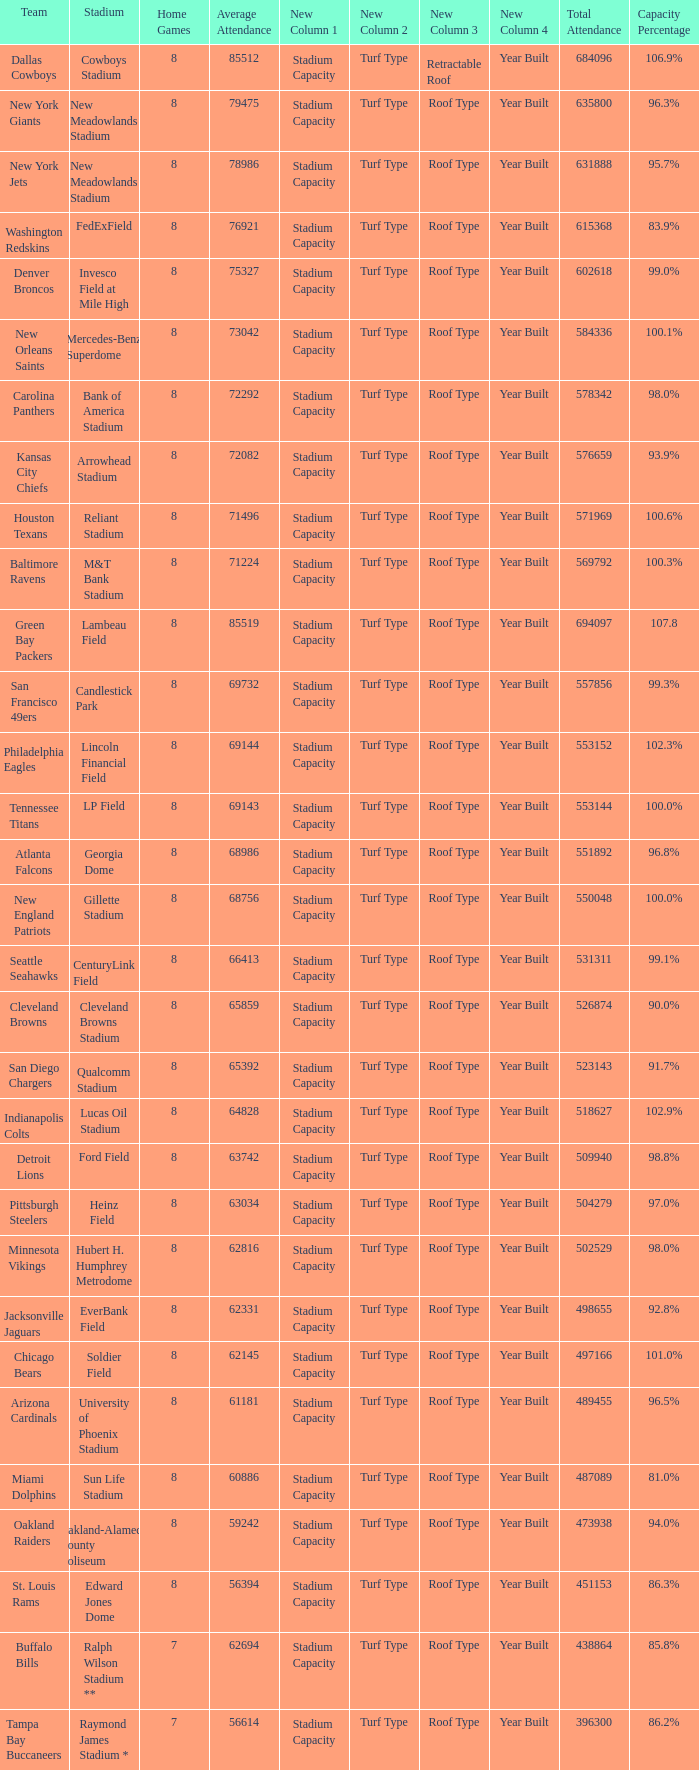Would you be able to parse every entry in this table? {'header': ['Team', 'Stadium', 'Home Games', 'Average Attendance', 'New Column 1', 'New Column 2', 'New Column 3', 'New Column 4', 'Total Attendance', 'Capacity Percentage'], 'rows': [['Dallas Cowboys', 'Cowboys Stadium', '8', '85512', 'Stadium Capacity', 'Turf Type', 'Retractable Roof', 'Year Built', '684096', '106.9%'], ['New York Giants', 'New Meadowlands Stadium', '8', '79475', 'Stadium Capacity', 'Turf Type', 'Roof Type', 'Year Built', '635800', '96.3%'], ['New York Jets', 'New Meadowlands Stadium', '8', '78986', 'Stadium Capacity', 'Turf Type', 'Roof Type', 'Year Built', '631888', '95.7%'], ['Washington Redskins', 'FedExField', '8', '76921', 'Stadium Capacity', 'Turf Type', 'Roof Type', 'Year Built', '615368', '83.9%'], ['Denver Broncos', 'Invesco Field at Mile High', '8', '75327', 'Stadium Capacity', 'Turf Type', 'Roof Type', 'Year Built', '602618', '99.0%'], ['New Orleans Saints', 'Mercedes-Benz Superdome', '8', '73042', 'Stadium Capacity', 'Turf Type', 'Roof Type', 'Year Built', '584336', '100.1%'], ['Carolina Panthers', 'Bank of America Stadium', '8', '72292', 'Stadium Capacity', 'Turf Type', 'Roof Type', 'Year Built', '578342', '98.0%'], ['Kansas City Chiefs', 'Arrowhead Stadium', '8', '72082', 'Stadium Capacity', 'Turf Type', 'Roof Type', 'Year Built', '576659', '93.9%'], ['Houston Texans', 'Reliant Stadium', '8', '71496', 'Stadium Capacity', 'Turf Type', 'Roof Type', 'Year Built', '571969', '100.6%'], ['Baltimore Ravens', 'M&T Bank Stadium', '8', '71224', 'Stadium Capacity', 'Turf Type', 'Roof Type', 'Year Built', '569792', '100.3%'], ['Green Bay Packers', 'Lambeau Field', '8', '85519', 'Stadium Capacity', 'Turf Type', 'Roof Type', 'Year Built', '694097', '107.8'], ['San Francisco 49ers', 'Candlestick Park', '8', '69732', 'Stadium Capacity', 'Turf Type', 'Roof Type', 'Year Built', '557856', '99.3%'], ['Philadelphia Eagles', 'Lincoln Financial Field', '8', '69144', 'Stadium Capacity', 'Turf Type', 'Roof Type', 'Year Built', '553152', '102.3%'], ['Tennessee Titans', 'LP Field', '8', '69143', 'Stadium Capacity', 'Turf Type', 'Roof Type', 'Year Built', '553144', '100.0%'], ['Atlanta Falcons', 'Georgia Dome', '8', '68986', 'Stadium Capacity', 'Turf Type', 'Roof Type', 'Year Built', '551892', '96.8%'], ['New England Patriots', 'Gillette Stadium', '8', '68756', 'Stadium Capacity', 'Turf Type', 'Roof Type', 'Year Built', '550048', '100.0%'], ['Seattle Seahawks', 'CenturyLink Field', '8', '66413', 'Stadium Capacity', 'Turf Type', 'Roof Type', 'Year Built', '531311', '99.1%'], ['Cleveland Browns', 'Cleveland Browns Stadium', '8', '65859', 'Stadium Capacity', 'Turf Type', 'Roof Type', 'Year Built', '526874', '90.0%'], ['San Diego Chargers', 'Qualcomm Stadium', '8', '65392', 'Stadium Capacity', 'Turf Type', 'Roof Type', 'Year Built', '523143', '91.7%'], ['Indianapolis Colts', 'Lucas Oil Stadium', '8', '64828', 'Stadium Capacity', 'Turf Type', 'Roof Type', 'Year Built', '518627', '102.9%'], ['Detroit Lions', 'Ford Field', '8', '63742', 'Stadium Capacity', 'Turf Type', 'Roof Type', 'Year Built', '509940', '98.8%'], ['Pittsburgh Steelers', 'Heinz Field', '8', '63034', 'Stadium Capacity', 'Turf Type', 'Roof Type', 'Year Built', '504279', '97.0%'], ['Minnesota Vikings', 'Hubert H. Humphrey Metrodome', '8', '62816', 'Stadium Capacity', 'Turf Type', 'Roof Type', 'Year Built', '502529', '98.0%'], ['Jacksonville Jaguars', 'EverBank Field', '8', '62331', 'Stadium Capacity', 'Turf Type', 'Roof Type', 'Year Built', '498655', '92.8%'], ['Chicago Bears', 'Soldier Field', '8', '62145', 'Stadium Capacity', 'Turf Type', 'Roof Type', 'Year Built', '497166', '101.0%'], ['Arizona Cardinals', 'University of Phoenix Stadium', '8', '61181', 'Stadium Capacity', 'Turf Type', 'Roof Type', 'Year Built', '489455', '96.5%'], ['Miami Dolphins', 'Sun Life Stadium', '8', '60886', 'Stadium Capacity', 'Turf Type', 'Roof Type', 'Year Built', '487089', '81.0%'], ['Oakland Raiders', 'Oakland-Alameda County Coliseum', '8', '59242', 'Stadium Capacity', 'Turf Type', 'Roof Type', 'Year Built', '473938', '94.0%'], ['St. Louis Rams', 'Edward Jones Dome', '8', '56394', 'Stadium Capacity', 'Turf Type', 'Roof Type', 'Year Built', '451153', '86.3%'], ['Buffalo Bills', 'Ralph Wilson Stadium **', '7', '62694', 'Stadium Capacity', 'Turf Type', 'Roof Type', 'Year Built', '438864', '85.8%'], ['Tampa Bay Buccaneers', 'Raymond James Stadium *', '7', '56614', 'Stadium Capacity', 'Turf Type', 'Roof Type', 'Year Built', '396300', '86.2%']]} What is the number listed in home games when the team is Seattle Seahawks? 8.0. 